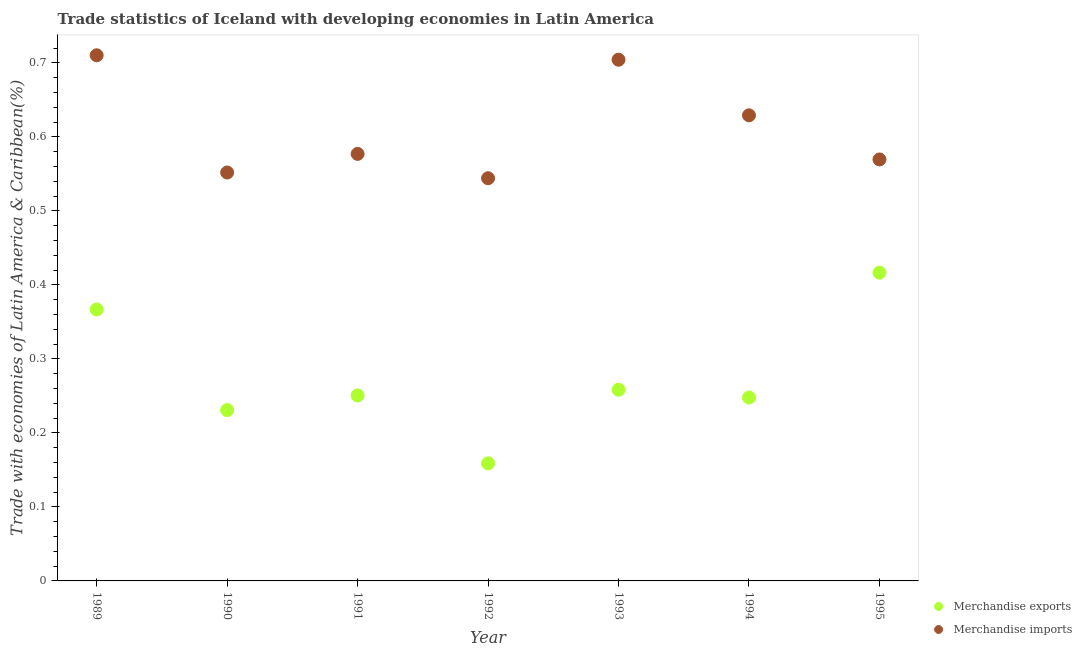How many different coloured dotlines are there?
Your answer should be compact. 2. Is the number of dotlines equal to the number of legend labels?
Give a very brief answer. Yes. What is the merchandise exports in 1989?
Provide a short and direct response. 0.37. Across all years, what is the maximum merchandise exports?
Make the answer very short. 0.42. Across all years, what is the minimum merchandise imports?
Your response must be concise. 0.54. In which year was the merchandise imports maximum?
Your answer should be very brief. 1989. In which year was the merchandise imports minimum?
Provide a succinct answer. 1992. What is the total merchandise imports in the graph?
Your response must be concise. 4.29. What is the difference between the merchandise exports in 1989 and that in 1991?
Your answer should be very brief. 0.12. What is the difference between the merchandise imports in 1995 and the merchandise exports in 1992?
Make the answer very short. 0.41. What is the average merchandise exports per year?
Give a very brief answer. 0.28. In the year 1994, what is the difference between the merchandise exports and merchandise imports?
Keep it short and to the point. -0.38. What is the ratio of the merchandise imports in 1991 to that in 1992?
Provide a succinct answer. 1.06. Is the difference between the merchandise exports in 1991 and 1992 greater than the difference between the merchandise imports in 1991 and 1992?
Make the answer very short. Yes. What is the difference between the highest and the second highest merchandise exports?
Your answer should be very brief. 0.05. What is the difference between the highest and the lowest merchandise imports?
Ensure brevity in your answer.  0.17. Does the merchandise imports monotonically increase over the years?
Your response must be concise. No. Is the merchandise imports strictly less than the merchandise exports over the years?
Make the answer very short. No. What is the difference between two consecutive major ticks on the Y-axis?
Provide a short and direct response. 0.1. Are the values on the major ticks of Y-axis written in scientific E-notation?
Provide a succinct answer. No. Does the graph contain grids?
Give a very brief answer. No. Where does the legend appear in the graph?
Ensure brevity in your answer.  Bottom right. How are the legend labels stacked?
Ensure brevity in your answer.  Vertical. What is the title of the graph?
Provide a succinct answer. Trade statistics of Iceland with developing economies in Latin America. Does "Net savings(excluding particulate emission damage)" appear as one of the legend labels in the graph?
Provide a short and direct response. No. What is the label or title of the Y-axis?
Offer a terse response. Trade with economies of Latin America & Caribbean(%). What is the Trade with economies of Latin America & Caribbean(%) in Merchandise exports in 1989?
Offer a terse response. 0.37. What is the Trade with economies of Latin America & Caribbean(%) in Merchandise imports in 1989?
Offer a very short reply. 0.71. What is the Trade with economies of Latin America & Caribbean(%) of Merchandise exports in 1990?
Offer a terse response. 0.23. What is the Trade with economies of Latin America & Caribbean(%) in Merchandise imports in 1990?
Provide a short and direct response. 0.55. What is the Trade with economies of Latin America & Caribbean(%) of Merchandise exports in 1991?
Keep it short and to the point. 0.25. What is the Trade with economies of Latin America & Caribbean(%) in Merchandise imports in 1991?
Your response must be concise. 0.58. What is the Trade with economies of Latin America & Caribbean(%) of Merchandise exports in 1992?
Your answer should be very brief. 0.16. What is the Trade with economies of Latin America & Caribbean(%) in Merchandise imports in 1992?
Offer a terse response. 0.54. What is the Trade with economies of Latin America & Caribbean(%) in Merchandise exports in 1993?
Give a very brief answer. 0.26. What is the Trade with economies of Latin America & Caribbean(%) in Merchandise imports in 1993?
Make the answer very short. 0.7. What is the Trade with economies of Latin America & Caribbean(%) of Merchandise exports in 1994?
Your answer should be compact. 0.25. What is the Trade with economies of Latin America & Caribbean(%) in Merchandise imports in 1994?
Make the answer very short. 0.63. What is the Trade with economies of Latin America & Caribbean(%) in Merchandise exports in 1995?
Offer a terse response. 0.42. What is the Trade with economies of Latin America & Caribbean(%) of Merchandise imports in 1995?
Your response must be concise. 0.57. Across all years, what is the maximum Trade with economies of Latin America & Caribbean(%) of Merchandise exports?
Your answer should be very brief. 0.42. Across all years, what is the maximum Trade with economies of Latin America & Caribbean(%) in Merchandise imports?
Provide a succinct answer. 0.71. Across all years, what is the minimum Trade with economies of Latin America & Caribbean(%) in Merchandise exports?
Your answer should be compact. 0.16. Across all years, what is the minimum Trade with economies of Latin America & Caribbean(%) of Merchandise imports?
Provide a short and direct response. 0.54. What is the total Trade with economies of Latin America & Caribbean(%) in Merchandise exports in the graph?
Provide a succinct answer. 1.93. What is the total Trade with economies of Latin America & Caribbean(%) of Merchandise imports in the graph?
Your response must be concise. 4.29. What is the difference between the Trade with economies of Latin America & Caribbean(%) in Merchandise exports in 1989 and that in 1990?
Provide a succinct answer. 0.14. What is the difference between the Trade with economies of Latin America & Caribbean(%) in Merchandise imports in 1989 and that in 1990?
Ensure brevity in your answer.  0.16. What is the difference between the Trade with economies of Latin America & Caribbean(%) in Merchandise exports in 1989 and that in 1991?
Your response must be concise. 0.12. What is the difference between the Trade with economies of Latin America & Caribbean(%) in Merchandise imports in 1989 and that in 1991?
Offer a terse response. 0.13. What is the difference between the Trade with economies of Latin America & Caribbean(%) of Merchandise exports in 1989 and that in 1992?
Ensure brevity in your answer.  0.21. What is the difference between the Trade with economies of Latin America & Caribbean(%) in Merchandise imports in 1989 and that in 1992?
Make the answer very short. 0.17. What is the difference between the Trade with economies of Latin America & Caribbean(%) of Merchandise exports in 1989 and that in 1993?
Provide a short and direct response. 0.11. What is the difference between the Trade with economies of Latin America & Caribbean(%) in Merchandise imports in 1989 and that in 1993?
Offer a terse response. 0.01. What is the difference between the Trade with economies of Latin America & Caribbean(%) in Merchandise exports in 1989 and that in 1994?
Your answer should be compact. 0.12. What is the difference between the Trade with economies of Latin America & Caribbean(%) of Merchandise imports in 1989 and that in 1994?
Give a very brief answer. 0.08. What is the difference between the Trade with economies of Latin America & Caribbean(%) of Merchandise exports in 1989 and that in 1995?
Offer a very short reply. -0.05. What is the difference between the Trade with economies of Latin America & Caribbean(%) of Merchandise imports in 1989 and that in 1995?
Ensure brevity in your answer.  0.14. What is the difference between the Trade with economies of Latin America & Caribbean(%) of Merchandise exports in 1990 and that in 1991?
Give a very brief answer. -0.02. What is the difference between the Trade with economies of Latin America & Caribbean(%) of Merchandise imports in 1990 and that in 1991?
Your answer should be very brief. -0.03. What is the difference between the Trade with economies of Latin America & Caribbean(%) in Merchandise exports in 1990 and that in 1992?
Provide a short and direct response. 0.07. What is the difference between the Trade with economies of Latin America & Caribbean(%) of Merchandise imports in 1990 and that in 1992?
Your answer should be very brief. 0.01. What is the difference between the Trade with economies of Latin America & Caribbean(%) of Merchandise exports in 1990 and that in 1993?
Your response must be concise. -0.03. What is the difference between the Trade with economies of Latin America & Caribbean(%) of Merchandise imports in 1990 and that in 1993?
Provide a succinct answer. -0.15. What is the difference between the Trade with economies of Latin America & Caribbean(%) of Merchandise exports in 1990 and that in 1994?
Give a very brief answer. -0.02. What is the difference between the Trade with economies of Latin America & Caribbean(%) in Merchandise imports in 1990 and that in 1994?
Provide a short and direct response. -0.08. What is the difference between the Trade with economies of Latin America & Caribbean(%) in Merchandise exports in 1990 and that in 1995?
Provide a succinct answer. -0.19. What is the difference between the Trade with economies of Latin America & Caribbean(%) in Merchandise imports in 1990 and that in 1995?
Provide a succinct answer. -0.02. What is the difference between the Trade with economies of Latin America & Caribbean(%) of Merchandise exports in 1991 and that in 1992?
Give a very brief answer. 0.09. What is the difference between the Trade with economies of Latin America & Caribbean(%) of Merchandise imports in 1991 and that in 1992?
Keep it short and to the point. 0.03. What is the difference between the Trade with economies of Latin America & Caribbean(%) in Merchandise exports in 1991 and that in 1993?
Make the answer very short. -0.01. What is the difference between the Trade with economies of Latin America & Caribbean(%) in Merchandise imports in 1991 and that in 1993?
Your response must be concise. -0.13. What is the difference between the Trade with economies of Latin America & Caribbean(%) in Merchandise exports in 1991 and that in 1994?
Provide a short and direct response. 0. What is the difference between the Trade with economies of Latin America & Caribbean(%) of Merchandise imports in 1991 and that in 1994?
Make the answer very short. -0.05. What is the difference between the Trade with economies of Latin America & Caribbean(%) in Merchandise exports in 1991 and that in 1995?
Your answer should be very brief. -0.17. What is the difference between the Trade with economies of Latin America & Caribbean(%) of Merchandise imports in 1991 and that in 1995?
Make the answer very short. 0.01. What is the difference between the Trade with economies of Latin America & Caribbean(%) in Merchandise exports in 1992 and that in 1993?
Keep it short and to the point. -0.1. What is the difference between the Trade with economies of Latin America & Caribbean(%) in Merchandise imports in 1992 and that in 1993?
Give a very brief answer. -0.16. What is the difference between the Trade with economies of Latin America & Caribbean(%) in Merchandise exports in 1992 and that in 1994?
Your answer should be compact. -0.09. What is the difference between the Trade with economies of Latin America & Caribbean(%) of Merchandise imports in 1992 and that in 1994?
Your answer should be very brief. -0.09. What is the difference between the Trade with economies of Latin America & Caribbean(%) in Merchandise exports in 1992 and that in 1995?
Provide a succinct answer. -0.26. What is the difference between the Trade with economies of Latin America & Caribbean(%) of Merchandise imports in 1992 and that in 1995?
Offer a terse response. -0.03. What is the difference between the Trade with economies of Latin America & Caribbean(%) of Merchandise exports in 1993 and that in 1994?
Offer a very short reply. 0.01. What is the difference between the Trade with economies of Latin America & Caribbean(%) in Merchandise imports in 1993 and that in 1994?
Your response must be concise. 0.08. What is the difference between the Trade with economies of Latin America & Caribbean(%) of Merchandise exports in 1993 and that in 1995?
Ensure brevity in your answer.  -0.16. What is the difference between the Trade with economies of Latin America & Caribbean(%) of Merchandise imports in 1993 and that in 1995?
Your answer should be very brief. 0.13. What is the difference between the Trade with economies of Latin America & Caribbean(%) in Merchandise exports in 1994 and that in 1995?
Offer a terse response. -0.17. What is the difference between the Trade with economies of Latin America & Caribbean(%) in Merchandise imports in 1994 and that in 1995?
Provide a succinct answer. 0.06. What is the difference between the Trade with economies of Latin America & Caribbean(%) in Merchandise exports in 1989 and the Trade with economies of Latin America & Caribbean(%) in Merchandise imports in 1990?
Your response must be concise. -0.19. What is the difference between the Trade with economies of Latin America & Caribbean(%) of Merchandise exports in 1989 and the Trade with economies of Latin America & Caribbean(%) of Merchandise imports in 1991?
Your answer should be compact. -0.21. What is the difference between the Trade with economies of Latin America & Caribbean(%) in Merchandise exports in 1989 and the Trade with economies of Latin America & Caribbean(%) in Merchandise imports in 1992?
Your answer should be very brief. -0.18. What is the difference between the Trade with economies of Latin America & Caribbean(%) in Merchandise exports in 1989 and the Trade with economies of Latin America & Caribbean(%) in Merchandise imports in 1993?
Provide a succinct answer. -0.34. What is the difference between the Trade with economies of Latin America & Caribbean(%) in Merchandise exports in 1989 and the Trade with economies of Latin America & Caribbean(%) in Merchandise imports in 1994?
Give a very brief answer. -0.26. What is the difference between the Trade with economies of Latin America & Caribbean(%) of Merchandise exports in 1989 and the Trade with economies of Latin America & Caribbean(%) of Merchandise imports in 1995?
Offer a terse response. -0.2. What is the difference between the Trade with economies of Latin America & Caribbean(%) in Merchandise exports in 1990 and the Trade with economies of Latin America & Caribbean(%) in Merchandise imports in 1991?
Give a very brief answer. -0.35. What is the difference between the Trade with economies of Latin America & Caribbean(%) of Merchandise exports in 1990 and the Trade with economies of Latin America & Caribbean(%) of Merchandise imports in 1992?
Provide a succinct answer. -0.31. What is the difference between the Trade with economies of Latin America & Caribbean(%) of Merchandise exports in 1990 and the Trade with economies of Latin America & Caribbean(%) of Merchandise imports in 1993?
Keep it short and to the point. -0.47. What is the difference between the Trade with economies of Latin America & Caribbean(%) in Merchandise exports in 1990 and the Trade with economies of Latin America & Caribbean(%) in Merchandise imports in 1994?
Your answer should be very brief. -0.4. What is the difference between the Trade with economies of Latin America & Caribbean(%) of Merchandise exports in 1990 and the Trade with economies of Latin America & Caribbean(%) of Merchandise imports in 1995?
Offer a terse response. -0.34. What is the difference between the Trade with economies of Latin America & Caribbean(%) of Merchandise exports in 1991 and the Trade with economies of Latin America & Caribbean(%) of Merchandise imports in 1992?
Your response must be concise. -0.29. What is the difference between the Trade with economies of Latin America & Caribbean(%) in Merchandise exports in 1991 and the Trade with economies of Latin America & Caribbean(%) in Merchandise imports in 1993?
Make the answer very short. -0.45. What is the difference between the Trade with economies of Latin America & Caribbean(%) of Merchandise exports in 1991 and the Trade with economies of Latin America & Caribbean(%) of Merchandise imports in 1994?
Provide a short and direct response. -0.38. What is the difference between the Trade with economies of Latin America & Caribbean(%) of Merchandise exports in 1991 and the Trade with economies of Latin America & Caribbean(%) of Merchandise imports in 1995?
Give a very brief answer. -0.32. What is the difference between the Trade with economies of Latin America & Caribbean(%) of Merchandise exports in 1992 and the Trade with economies of Latin America & Caribbean(%) of Merchandise imports in 1993?
Ensure brevity in your answer.  -0.55. What is the difference between the Trade with economies of Latin America & Caribbean(%) of Merchandise exports in 1992 and the Trade with economies of Latin America & Caribbean(%) of Merchandise imports in 1994?
Offer a very short reply. -0.47. What is the difference between the Trade with economies of Latin America & Caribbean(%) in Merchandise exports in 1992 and the Trade with economies of Latin America & Caribbean(%) in Merchandise imports in 1995?
Make the answer very short. -0.41. What is the difference between the Trade with economies of Latin America & Caribbean(%) of Merchandise exports in 1993 and the Trade with economies of Latin America & Caribbean(%) of Merchandise imports in 1994?
Keep it short and to the point. -0.37. What is the difference between the Trade with economies of Latin America & Caribbean(%) of Merchandise exports in 1993 and the Trade with economies of Latin America & Caribbean(%) of Merchandise imports in 1995?
Give a very brief answer. -0.31. What is the difference between the Trade with economies of Latin America & Caribbean(%) in Merchandise exports in 1994 and the Trade with economies of Latin America & Caribbean(%) in Merchandise imports in 1995?
Your response must be concise. -0.32. What is the average Trade with economies of Latin America & Caribbean(%) in Merchandise exports per year?
Make the answer very short. 0.28. What is the average Trade with economies of Latin America & Caribbean(%) in Merchandise imports per year?
Provide a short and direct response. 0.61. In the year 1989, what is the difference between the Trade with economies of Latin America & Caribbean(%) of Merchandise exports and Trade with economies of Latin America & Caribbean(%) of Merchandise imports?
Make the answer very short. -0.34. In the year 1990, what is the difference between the Trade with economies of Latin America & Caribbean(%) in Merchandise exports and Trade with economies of Latin America & Caribbean(%) in Merchandise imports?
Your answer should be very brief. -0.32. In the year 1991, what is the difference between the Trade with economies of Latin America & Caribbean(%) of Merchandise exports and Trade with economies of Latin America & Caribbean(%) of Merchandise imports?
Ensure brevity in your answer.  -0.33. In the year 1992, what is the difference between the Trade with economies of Latin America & Caribbean(%) of Merchandise exports and Trade with economies of Latin America & Caribbean(%) of Merchandise imports?
Offer a terse response. -0.39. In the year 1993, what is the difference between the Trade with economies of Latin America & Caribbean(%) of Merchandise exports and Trade with economies of Latin America & Caribbean(%) of Merchandise imports?
Provide a succinct answer. -0.45. In the year 1994, what is the difference between the Trade with economies of Latin America & Caribbean(%) in Merchandise exports and Trade with economies of Latin America & Caribbean(%) in Merchandise imports?
Give a very brief answer. -0.38. In the year 1995, what is the difference between the Trade with economies of Latin America & Caribbean(%) of Merchandise exports and Trade with economies of Latin America & Caribbean(%) of Merchandise imports?
Ensure brevity in your answer.  -0.15. What is the ratio of the Trade with economies of Latin America & Caribbean(%) in Merchandise exports in 1989 to that in 1990?
Your answer should be very brief. 1.59. What is the ratio of the Trade with economies of Latin America & Caribbean(%) in Merchandise imports in 1989 to that in 1990?
Offer a very short reply. 1.29. What is the ratio of the Trade with economies of Latin America & Caribbean(%) of Merchandise exports in 1989 to that in 1991?
Provide a short and direct response. 1.46. What is the ratio of the Trade with economies of Latin America & Caribbean(%) of Merchandise imports in 1989 to that in 1991?
Provide a succinct answer. 1.23. What is the ratio of the Trade with economies of Latin America & Caribbean(%) of Merchandise exports in 1989 to that in 1992?
Offer a terse response. 2.31. What is the ratio of the Trade with economies of Latin America & Caribbean(%) of Merchandise imports in 1989 to that in 1992?
Offer a very short reply. 1.31. What is the ratio of the Trade with economies of Latin America & Caribbean(%) in Merchandise exports in 1989 to that in 1993?
Give a very brief answer. 1.42. What is the ratio of the Trade with economies of Latin America & Caribbean(%) in Merchandise imports in 1989 to that in 1993?
Give a very brief answer. 1.01. What is the ratio of the Trade with economies of Latin America & Caribbean(%) in Merchandise exports in 1989 to that in 1994?
Your response must be concise. 1.48. What is the ratio of the Trade with economies of Latin America & Caribbean(%) of Merchandise imports in 1989 to that in 1994?
Provide a short and direct response. 1.13. What is the ratio of the Trade with economies of Latin America & Caribbean(%) in Merchandise exports in 1989 to that in 1995?
Give a very brief answer. 0.88. What is the ratio of the Trade with economies of Latin America & Caribbean(%) in Merchandise imports in 1989 to that in 1995?
Your response must be concise. 1.25. What is the ratio of the Trade with economies of Latin America & Caribbean(%) in Merchandise exports in 1990 to that in 1991?
Your answer should be compact. 0.92. What is the ratio of the Trade with economies of Latin America & Caribbean(%) in Merchandise imports in 1990 to that in 1991?
Your response must be concise. 0.96. What is the ratio of the Trade with economies of Latin America & Caribbean(%) in Merchandise exports in 1990 to that in 1992?
Make the answer very short. 1.45. What is the ratio of the Trade with economies of Latin America & Caribbean(%) in Merchandise imports in 1990 to that in 1992?
Provide a succinct answer. 1.01. What is the ratio of the Trade with economies of Latin America & Caribbean(%) of Merchandise exports in 1990 to that in 1993?
Your response must be concise. 0.89. What is the ratio of the Trade with economies of Latin America & Caribbean(%) in Merchandise imports in 1990 to that in 1993?
Your answer should be compact. 0.78. What is the ratio of the Trade with economies of Latin America & Caribbean(%) in Merchandise exports in 1990 to that in 1994?
Ensure brevity in your answer.  0.93. What is the ratio of the Trade with economies of Latin America & Caribbean(%) of Merchandise imports in 1990 to that in 1994?
Offer a terse response. 0.88. What is the ratio of the Trade with economies of Latin America & Caribbean(%) in Merchandise exports in 1990 to that in 1995?
Provide a short and direct response. 0.55. What is the ratio of the Trade with economies of Latin America & Caribbean(%) in Merchandise imports in 1990 to that in 1995?
Your answer should be compact. 0.97. What is the ratio of the Trade with economies of Latin America & Caribbean(%) in Merchandise exports in 1991 to that in 1992?
Your response must be concise. 1.58. What is the ratio of the Trade with economies of Latin America & Caribbean(%) in Merchandise imports in 1991 to that in 1992?
Keep it short and to the point. 1.06. What is the ratio of the Trade with economies of Latin America & Caribbean(%) of Merchandise exports in 1991 to that in 1993?
Offer a terse response. 0.97. What is the ratio of the Trade with economies of Latin America & Caribbean(%) in Merchandise imports in 1991 to that in 1993?
Provide a short and direct response. 0.82. What is the ratio of the Trade with economies of Latin America & Caribbean(%) of Merchandise exports in 1991 to that in 1994?
Ensure brevity in your answer.  1.01. What is the ratio of the Trade with economies of Latin America & Caribbean(%) of Merchandise imports in 1991 to that in 1994?
Give a very brief answer. 0.92. What is the ratio of the Trade with economies of Latin America & Caribbean(%) in Merchandise exports in 1991 to that in 1995?
Offer a very short reply. 0.6. What is the ratio of the Trade with economies of Latin America & Caribbean(%) of Merchandise imports in 1991 to that in 1995?
Provide a succinct answer. 1.01. What is the ratio of the Trade with economies of Latin America & Caribbean(%) of Merchandise exports in 1992 to that in 1993?
Your response must be concise. 0.62. What is the ratio of the Trade with economies of Latin America & Caribbean(%) in Merchandise imports in 1992 to that in 1993?
Your answer should be very brief. 0.77. What is the ratio of the Trade with economies of Latin America & Caribbean(%) of Merchandise exports in 1992 to that in 1994?
Give a very brief answer. 0.64. What is the ratio of the Trade with economies of Latin America & Caribbean(%) of Merchandise imports in 1992 to that in 1994?
Provide a succinct answer. 0.86. What is the ratio of the Trade with economies of Latin America & Caribbean(%) of Merchandise exports in 1992 to that in 1995?
Offer a very short reply. 0.38. What is the ratio of the Trade with economies of Latin America & Caribbean(%) in Merchandise imports in 1992 to that in 1995?
Offer a terse response. 0.96. What is the ratio of the Trade with economies of Latin America & Caribbean(%) of Merchandise exports in 1993 to that in 1994?
Your answer should be very brief. 1.04. What is the ratio of the Trade with economies of Latin America & Caribbean(%) of Merchandise imports in 1993 to that in 1994?
Your response must be concise. 1.12. What is the ratio of the Trade with economies of Latin America & Caribbean(%) in Merchandise exports in 1993 to that in 1995?
Ensure brevity in your answer.  0.62. What is the ratio of the Trade with economies of Latin America & Caribbean(%) of Merchandise imports in 1993 to that in 1995?
Keep it short and to the point. 1.24. What is the ratio of the Trade with economies of Latin America & Caribbean(%) in Merchandise exports in 1994 to that in 1995?
Offer a terse response. 0.59. What is the ratio of the Trade with economies of Latin America & Caribbean(%) of Merchandise imports in 1994 to that in 1995?
Your answer should be compact. 1.1. What is the difference between the highest and the second highest Trade with economies of Latin America & Caribbean(%) of Merchandise exports?
Make the answer very short. 0.05. What is the difference between the highest and the second highest Trade with economies of Latin America & Caribbean(%) in Merchandise imports?
Your answer should be very brief. 0.01. What is the difference between the highest and the lowest Trade with economies of Latin America & Caribbean(%) of Merchandise exports?
Ensure brevity in your answer.  0.26. What is the difference between the highest and the lowest Trade with economies of Latin America & Caribbean(%) of Merchandise imports?
Ensure brevity in your answer.  0.17. 